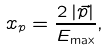Convert formula to latex. <formula><loc_0><loc_0><loc_500><loc_500>x _ { p } = \frac { 2 \left | \vec { p } \right | } { E _ { \max } } ,</formula> 